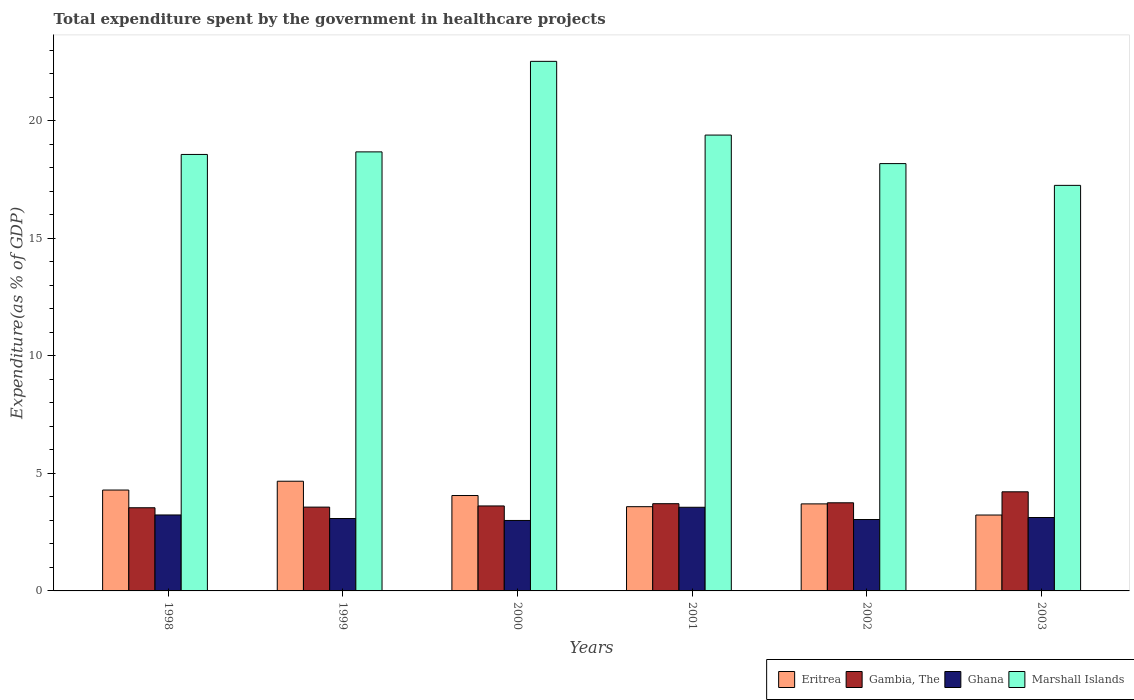Are the number of bars on each tick of the X-axis equal?
Provide a succinct answer. Yes. How many bars are there on the 1st tick from the right?
Offer a terse response. 4. What is the label of the 3rd group of bars from the left?
Offer a very short reply. 2000. In how many cases, is the number of bars for a given year not equal to the number of legend labels?
Make the answer very short. 0. What is the total expenditure spent by the government in healthcare projects in Marshall Islands in 2002?
Your answer should be compact. 18.18. Across all years, what is the maximum total expenditure spent by the government in healthcare projects in Marshall Islands?
Offer a terse response. 22.53. Across all years, what is the minimum total expenditure spent by the government in healthcare projects in Marshall Islands?
Your answer should be compact. 17.26. What is the total total expenditure spent by the government in healthcare projects in Eritrea in the graph?
Your answer should be compact. 23.54. What is the difference between the total expenditure spent by the government in healthcare projects in Ghana in 1998 and that in 2000?
Keep it short and to the point. 0.23. What is the difference between the total expenditure spent by the government in healthcare projects in Gambia, The in 2000 and the total expenditure spent by the government in healthcare projects in Eritrea in 2001?
Offer a terse response. 0.03. What is the average total expenditure spent by the government in healthcare projects in Ghana per year?
Offer a very short reply. 3.17. In the year 2001, what is the difference between the total expenditure spent by the government in healthcare projects in Eritrea and total expenditure spent by the government in healthcare projects in Marshall Islands?
Ensure brevity in your answer.  -15.81. What is the ratio of the total expenditure spent by the government in healthcare projects in Marshall Islands in 2001 to that in 2003?
Provide a short and direct response. 1.12. Is the total expenditure spent by the government in healthcare projects in Gambia, The in 2000 less than that in 2001?
Your answer should be compact. Yes. What is the difference between the highest and the second highest total expenditure spent by the government in healthcare projects in Gambia, The?
Ensure brevity in your answer.  0.47. What is the difference between the highest and the lowest total expenditure spent by the government in healthcare projects in Ghana?
Ensure brevity in your answer.  0.56. In how many years, is the total expenditure spent by the government in healthcare projects in Gambia, The greater than the average total expenditure spent by the government in healthcare projects in Gambia, The taken over all years?
Keep it short and to the point. 2. What does the 4th bar from the left in 2002 represents?
Your answer should be compact. Marshall Islands. What does the 3rd bar from the right in 2000 represents?
Make the answer very short. Gambia, The. Are all the bars in the graph horizontal?
Your response must be concise. No. How many years are there in the graph?
Provide a succinct answer. 6. Are the values on the major ticks of Y-axis written in scientific E-notation?
Keep it short and to the point. No. Does the graph contain grids?
Your answer should be very brief. No. Where does the legend appear in the graph?
Your response must be concise. Bottom right. How are the legend labels stacked?
Your answer should be very brief. Horizontal. What is the title of the graph?
Your response must be concise. Total expenditure spent by the government in healthcare projects. Does "Latin America(all income levels)" appear as one of the legend labels in the graph?
Your response must be concise. No. What is the label or title of the Y-axis?
Your answer should be very brief. Expenditure(as % of GDP). What is the Expenditure(as % of GDP) of Eritrea in 1998?
Your answer should be very brief. 4.29. What is the Expenditure(as % of GDP) of Gambia, The in 1998?
Your answer should be compact. 3.54. What is the Expenditure(as % of GDP) in Ghana in 1998?
Your response must be concise. 3.23. What is the Expenditure(as % of GDP) in Marshall Islands in 1998?
Offer a terse response. 18.57. What is the Expenditure(as % of GDP) in Eritrea in 1999?
Keep it short and to the point. 4.67. What is the Expenditure(as % of GDP) in Gambia, The in 1999?
Keep it short and to the point. 3.57. What is the Expenditure(as % of GDP) of Ghana in 1999?
Keep it short and to the point. 3.08. What is the Expenditure(as % of GDP) in Marshall Islands in 1999?
Offer a very short reply. 18.68. What is the Expenditure(as % of GDP) in Eritrea in 2000?
Keep it short and to the point. 4.06. What is the Expenditure(as % of GDP) in Gambia, The in 2000?
Ensure brevity in your answer.  3.62. What is the Expenditure(as % of GDP) of Ghana in 2000?
Ensure brevity in your answer.  3. What is the Expenditure(as % of GDP) in Marshall Islands in 2000?
Offer a terse response. 22.53. What is the Expenditure(as % of GDP) in Eritrea in 2001?
Provide a short and direct response. 3.58. What is the Expenditure(as % of GDP) in Gambia, The in 2001?
Give a very brief answer. 3.71. What is the Expenditure(as % of GDP) in Ghana in 2001?
Provide a succinct answer. 3.56. What is the Expenditure(as % of GDP) in Marshall Islands in 2001?
Your answer should be compact. 19.4. What is the Expenditure(as % of GDP) in Eritrea in 2002?
Give a very brief answer. 3.7. What is the Expenditure(as % of GDP) in Gambia, The in 2002?
Offer a very short reply. 3.75. What is the Expenditure(as % of GDP) of Ghana in 2002?
Offer a very short reply. 3.04. What is the Expenditure(as % of GDP) of Marshall Islands in 2002?
Keep it short and to the point. 18.18. What is the Expenditure(as % of GDP) of Eritrea in 2003?
Make the answer very short. 3.23. What is the Expenditure(as % of GDP) in Gambia, The in 2003?
Give a very brief answer. 4.22. What is the Expenditure(as % of GDP) of Ghana in 2003?
Give a very brief answer. 3.12. What is the Expenditure(as % of GDP) of Marshall Islands in 2003?
Make the answer very short. 17.26. Across all years, what is the maximum Expenditure(as % of GDP) of Eritrea?
Give a very brief answer. 4.67. Across all years, what is the maximum Expenditure(as % of GDP) in Gambia, The?
Provide a short and direct response. 4.22. Across all years, what is the maximum Expenditure(as % of GDP) of Ghana?
Make the answer very short. 3.56. Across all years, what is the maximum Expenditure(as % of GDP) of Marshall Islands?
Your response must be concise. 22.53. Across all years, what is the minimum Expenditure(as % of GDP) in Eritrea?
Offer a very short reply. 3.23. Across all years, what is the minimum Expenditure(as % of GDP) in Gambia, The?
Provide a succinct answer. 3.54. Across all years, what is the minimum Expenditure(as % of GDP) of Ghana?
Ensure brevity in your answer.  3. Across all years, what is the minimum Expenditure(as % of GDP) in Marshall Islands?
Offer a terse response. 17.26. What is the total Expenditure(as % of GDP) in Eritrea in the graph?
Your answer should be very brief. 23.54. What is the total Expenditure(as % of GDP) in Gambia, The in the graph?
Offer a very short reply. 22.4. What is the total Expenditure(as % of GDP) in Ghana in the graph?
Your response must be concise. 19.03. What is the total Expenditure(as % of GDP) in Marshall Islands in the graph?
Your response must be concise. 114.62. What is the difference between the Expenditure(as % of GDP) in Eritrea in 1998 and that in 1999?
Ensure brevity in your answer.  -0.37. What is the difference between the Expenditure(as % of GDP) in Gambia, The in 1998 and that in 1999?
Offer a very short reply. -0.03. What is the difference between the Expenditure(as % of GDP) of Ghana in 1998 and that in 1999?
Ensure brevity in your answer.  0.15. What is the difference between the Expenditure(as % of GDP) of Marshall Islands in 1998 and that in 1999?
Ensure brevity in your answer.  -0.11. What is the difference between the Expenditure(as % of GDP) in Eritrea in 1998 and that in 2000?
Offer a very short reply. 0.23. What is the difference between the Expenditure(as % of GDP) of Gambia, The in 1998 and that in 2000?
Provide a short and direct response. -0.08. What is the difference between the Expenditure(as % of GDP) in Ghana in 1998 and that in 2000?
Provide a short and direct response. 0.23. What is the difference between the Expenditure(as % of GDP) of Marshall Islands in 1998 and that in 2000?
Your response must be concise. -3.96. What is the difference between the Expenditure(as % of GDP) in Eritrea in 1998 and that in 2001?
Provide a succinct answer. 0.71. What is the difference between the Expenditure(as % of GDP) in Gambia, The in 1998 and that in 2001?
Provide a short and direct response. -0.17. What is the difference between the Expenditure(as % of GDP) of Ghana in 1998 and that in 2001?
Your answer should be very brief. -0.33. What is the difference between the Expenditure(as % of GDP) in Marshall Islands in 1998 and that in 2001?
Offer a terse response. -0.82. What is the difference between the Expenditure(as % of GDP) in Eritrea in 1998 and that in 2002?
Provide a short and direct response. 0.59. What is the difference between the Expenditure(as % of GDP) of Gambia, The in 1998 and that in 2002?
Your answer should be very brief. -0.21. What is the difference between the Expenditure(as % of GDP) of Ghana in 1998 and that in 2002?
Your answer should be compact. 0.19. What is the difference between the Expenditure(as % of GDP) of Marshall Islands in 1998 and that in 2002?
Offer a terse response. 0.39. What is the difference between the Expenditure(as % of GDP) of Eritrea in 1998 and that in 2003?
Your answer should be very brief. 1.06. What is the difference between the Expenditure(as % of GDP) in Gambia, The in 1998 and that in 2003?
Make the answer very short. -0.68. What is the difference between the Expenditure(as % of GDP) of Ghana in 1998 and that in 2003?
Your response must be concise. 0.11. What is the difference between the Expenditure(as % of GDP) in Marshall Islands in 1998 and that in 2003?
Provide a short and direct response. 1.32. What is the difference between the Expenditure(as % of GDP) in Eritrea in 1999 and that in 2000?
Your answer should be compact. 0.61. What is the difference between the Expenditure(as % of GDP) in Gambia, The in 1999 and that in 2000?
Keep it short and to the point. -0.05. What is the difference between the Expenditure(as % of GDP) of Ghana in 1999 and that in 2000?
Provide a short and direct response. 0.08. What is the difference between the Expenditure(as % of GDP) in Marshall Islands in 1999 and that in 2000?
Offer a very short reply. -3.85. What is the difference between the Expenditure(as % of GDP) in Eritrea in 1999 and that in 2001?
Provide a short and direct response. 1.08. What is the difference between the Expenditure(as % of GDP) in Gambia, The in 1999 and that in 2001?
Your response must be concise. -0.15. What is the difference between the Expenditure(as % of GDP) of Ghana in 1999 and that in 2001?
Provide a succinct answer. -0.48. What is the difference between the Expenditure(as % of GDP) in Marshall Islands in 1999 and that in 2001?
Keep it short and to the point. -0.72. What is the difference between the Expenditure(as % of GDP) in Eritrea in 1999 and that in 2002?
Your answer should be very brief. 0.96. What is the difference between the Expenditure(as % of GDP) in Gambia, The in 1999 and that in 2002?
Give a very brief answer. -0.18. What is the difference between the Expenditure(as % of GDP) of Ghana in 1999 and that in 2002?
Make the answer very short. 0.04. What is the difference between the Expenditure(as % of GDP) of Marshall Islands in 1999 and that in 2002?
Provide a short and direct response. 0.5. What is the difference between the Expenditure(as % of GDP) in Eritrea in 1999 and that in 2003?
Your answer should be compact. 1.44. What is the difference between the Expenditure(as % of GDP) of Gambia, The in 1999 and that in 2003?
Offer a terse response. -0.65. What is the difference between the Expenditure(as % of GDP) of Ghana in 1999 and that in 2003?
Offer a terse response. -0.04. What is the difference between the Expenditure(as % of GDP) in Marshall Islands in 1999 and that in 2003?
Provide a short and direct response. 1.42. What is the difference between the Expenditure(as % of GDP) in Eritrea in 2000 and that in 2001?
Keep it short and to the point. 0.48. What is the difference between the Expenditure(as % of GDP) in Gambia, The in 2000 and that in 2001?
Provide a short and direct response. -0.1. What is the difference between the Expenditure(as % of GDP) of Ghana in 2000 and that in 2001?
Offer a terse response. -0.56. What is the difference between the Expenditure(as % of GDP) in Marshall Islands in 2000 and that in 2001?
Offer a terse response. 3.14. What is the difference between the Expenditure(as % of GDP) in Eritrea in 2000 and that in 2002?
Offer a very short reply. 0.36. What is the difference between the Expenditure(as % of GDP) of Gambia, The in 2000 and that in 2002?
Offer a very short reply. -0.13. What is the difference between the Expenditure(as % of GDP) of Ghana in 2000 and that in 2002?
Offer a very short reply. -0.04. What is the difference between the Expenditure(as % of GDP) of Marshall Islands in 2000 and that in 2002?
Your response must be concise. 4.35. What is the difference between the Expenditure(as % of GDP) of Eritrea in 2000 and that in 2003?
Provide a short and direct response. 0.83. What is the difference between the Expenditure(as % of GDP) in Gambia, The in 2000 and that in 2003?
Your answer should be very brief. -0.6. What is the difference between the Expenditure(as % of GDP) of Ghana in 2000 and that in 2003?
Your answer should be compact. -0.13. What is the difference between the Expenditure(as % of GDP) in Marshall Islands in 2000 and that in 2003?
Make the answer very short. 5.28. What is the difference between the Expenditure(as % of GDP) in Eritrea in 2001 and that in 2002?
Ensure brevity in your answer.  -0.12. What is the difference between the Expenditure(as % of GDP) in Gambia, The in 2001 and that in 2002?
Make the answer very short. -0.04. What is the difference between the Expenditure(as % of GDP) in Ghana in 2001 and that in 2002?
Offer a terse response. 0.52. What is the difference between the Expenditure(as % of GDP) of Marshall Islands in 2001 and that in 2002?
Provide a short and direct response. 1.21. What is the difference between the Expenditure(as % of GDP) of Eritrea in 2001 and that in 2003?
Ensure brevity in your answer.  0.36. What is the difference between the Expenditure(as % of GDP) of Gambia, The in 2001 and that in 2003?
Your response must be concise. -0.51. What is the difference between the Expenditure(as % of GDP) of Ghana in 2001 and that in 2003?
Your answer should be compact. 0.44. What is the difference between the Expenditure(as % of GDP) in Marshall Islands in 2001 and that in 2003?
Give a very brief answer. 2.14. What is the difference between the Expenditure(as % of GDP) of Eritrea in 2002 and that in 2003?
Offer a very short reply. 0.47. What is the difference between the Expenditure(as % of GDP) of Gambia, The in 2002 and that in 2003?
Give a very brief answer. -0.47. What is the difference between the Expenditure(as % of GDP) in Ghana in 2002 and that in 2003?
Provide a short and direct response. -0.09. What is the difference between the Expenditure(as % of GDP) of Marshall Islands in 2002 and that in 2003?
Your answer should be compact. 0.93. What is the difference between the Expenditure(as % of GDP) in Eritrea in 1998 and the Expenditure(as % of GDP) in Gambia, The in 1999?
Provide a succinct answer. 0.73. What is the difference between the Expenditure(as % of GDP) in Eritrea in 1998 and the Expenditure(as % of GDP) in Ghana in 1999?
Ensure brevity in your answer.  1.21. What is the difference between the Expenditure(as % of GDP) in Eritrea in 1998 and the Expenditure(as % of GDP) in Marshall Islands in 1999?
Your answer should be compact. -14.39. What is the difference between the Expenditure(as % of GDP) in Gambia, The in 1998 and the Expenditure(as % of GDP) in Ghana in 1999?
Offer a very short reply. 0.46. What is the difference between the Expenditure(as % of GDP) of Gambia, The in 1998 and the Expenditure(as % of GDP) of Marshall Islands in 1999?
Keep it short and to the point. -15.14. What is the difference between the Expenditure(as % of GDP) in Ghana in 1998 and the Expenditure(as % of GDP) in Marshall Islands in 1999?
Your answer should be compact. -15.45. What is the difference between the Expenditure(as % of GDP) in Eritrea in 1998 and the Expenditure(as % of GDP) in Gambia, The in 2000?
Ensure brevity in your answer.  0.68. What is the difference between the Expenditure(as % of GDP) in Eritrea in 1998 and the Expenditure(as % of GDP) in Ghana in 2000?
Offer a very short reply. 1.29. What is the difference between the Expenditure(as % of GDP) of Eritrea in 1998 and the Expenditure(as % of GDP) of Marshall Islands in 2000?
Provide a succinct answer. -18.24. What is the difference between the Expenditure(as % of GDP) of Gambia, The in 1998 and the Expenditure(as % of GDP) of Ghana in 2000?
Provide a short and direct response. 0.54. What is the difference between the Expenditure(as % of GDP) in Gambia, The in 1998 and the Expenditure(as % of GDP) in Marshall Islands in 2000?
Offer a terse response. -18.99. What is the difference between the Expenditure(as % of GDP) in Ghana in 1998 and the Expenditure(as % of GDP) in Marshall Islands in 2000?
Make the answer very short. -19.3. What is the difference between the Expenditure(as % of GDP) of Eritrea in 1998 and the Expenditure(as % of GDP) of Gambia, The in 2001?
Your answer should be compact. 0.58. What is the difference between the Expenditure(as % of GDP) of Eritrea in 1998 and the Expenditure(as % of GDP) of Ghana in 2001?
Make the answer very short. 0.73. What is the difference between the Expenditure(as % of GDP) of Eritrea in 1998 and the Expenditure(as % of GDP) of Marshall Islands in 2001?
Your answer should be compact. -15.1. What is the difference between the Expenditure(as % of GDP) of Gambia, The in 1998 and the Expenditure(as % of GDP) of Ghana in 2001?
Give a very brief answer. -0.02. What is the difference between the Expenditure(as % of GDP) of Gambia, The in 1998 and the Expenditure(as % of GDP) of Marshall Islands in 2001?
Make the answer very short. -15.86. What is the difference between the Expenditure(as % of GDP) in Ghana in 1998 and the Expenditure(as % of GDP) in Marshall Islands in 2001?
Keep it short and to the point. -16.16. What is the difference between the Expenditure(as % of GDP) in Eritrea in 1998 and the Expenditure(as % of GDP) in Gambia, The in 2002?
Offer a very short reply. 0.54. What is the difference between the Expenditure(as % of GDP) in Eritrea in 1998 and the Expenditure(as % of GDP) in Ghana in 2002?
Your answer should be compact. 1.25. What is the difference between the Expenditure(as % of GDP) of Eritrea in 1998 and the Expenditure(as % of GDP) of Marshall Islands in 2002?
Offer a terse response. -13.89. What is the difference between the Expenditure(as % of GDP) in Gambia, The in 1998 and the Expenditure(as % of GDP) in Ghana in 2002?
Provide a short and direct response. 0.5. What is the difference between the Expenditure(as % of GDP) in Gambia, The in 1998 and the Expenditure(as % of GDP) in Marshall Islands in 2002?
Provide a succinct answer. -14.64. What is the difference between the Expenditure(as % of GDP) in Ghana in 1998 and the Expenditure(as % of GDP) in Marshall Islands in 2002?
Your answer should be compact. -14.95. What is the difference between the Expenditure(as % of GDP) of Eritrea in 1998 and the Expenditure(as % of GDP) of Gambia, The in 2003?
Offer a terse response. 0.08. What is the difference between the Expenditure(as % of GDP) in Eritrea in 1998 and the Expenditure(as % of GDP) in Ghana in 2003?
Your answer should be very brief. 1.17. What is the difference between the Expenditure(as % of GDP) of Eritrea in 1998 and the Expenditure(as % of GDP) of Marshall Islands in 2003?
Give a very brief answer. -12.96. What is the difference between the Expenditure(as % of GDP) of Gambia, The in 1998 and the Expenditure(as % of GDP) of Ghana in 2003?
Offer a terse response. 0.41. What is the difference between the Expenditure(as % of GDP) in Gambia, The in 1998 and the Expenditure(as % of GDP) in Marshall Islands in 2003?
Your answer should be compact. -13.72. What is the difference between the Expenditure(as % of GDP) of Ghana in 1998 and the Expenditure(as % of GDP) of Marshall Islands in 2003?
Offer a very short reply. -14.02. What is the difference between the Expenditure(as % of GDP) in Eritrea in 1999 and the Expenditure(as % of GDP) in Gambia, The in 2000?
Offer a terse response. 1.05. What is the difference between the Expenditure(as % of GDP) in Eritrea in 1999 and the Expenditure(as % of GDP) in Ghana in 2000?
Your response must be concise. 1.67. What is the difference between the Expenditure(as % of GDP) in Eritrea in 1999 and the Expenditure(as % of GDP) in Marshall Islands in 2000?
Provide a succinct answer. -17.87. What is the difference between the Expenditure(as % of GDP) in Gambia, The in 1999 and the Expenditure(as % of GDP) in Ghana in 2000?
Offer a very short reply. 0.57. What is the difference between the Expenditure(as % of GDP) of Gambia, The in 1999 and the Expenditure(as % of GDP) of Marshall Islands in 2000?
Your answer should be very brief. -18.97. What is the difference between the Expenditure(as % of GDP) of Ghana in 1999 and the Expenditure(as % of GDP) of Marshall Islands in 2000?
Your response must be concise. -19.45. What is the difference between the Expenditure(as % of GDP) of Eritrea in 1999 and the Expenditure(as % of GDP) of Gambia, The in 2001?
Your answer should be compact. 0.96. What is the difference between the Expenditure(as % of GDP) in Eritrea in 1999 and the Expenditure(as % of GDP) in Ghana in 2001?
Your answer should be compact. 1.11. What is the difference between the Expenditure(as % of GDP) of Eritrea in 1999 and the Expenditure(as % of GDP) of Marshall Islands in 2001?
Give a very brief answer. -14.73. What is the difference between the Expenditure(as % of GDP) in Gambia, The in 1999 and the Expenditure(as % of GDP) in Ghana in 2001?
Your response must be concise. 0.01. What is the difference between the Expenditure(as % of GDP) in Gambia, The in 1999 and the Expenditure(as % of GDP) in Marshall Islands in 2001?
Give a very brief answer. -15.83. What is the difference between the Expenditure(as % of GDP) in Ghana in 1999 and the Expenditure(as % of GDP) in Marshall Islands in 2001?
Ensure brevity in your answer.  -16.32. What is the difference between the Expenditure(as % of GDP) of Eritrea in 1999 and the Expenditure(as % of GDP) of Gambia, The in 2002?
Your answer should be compact. 0.92. What is the difference between the Expenditure(as % of GDP) of Eritrea in 1999 and the Expenditure(as % of GDP) of Ghana in 2002?
Offer a terse response. 1.63. What is the difference between the Expenditure(as % of GDP) in Eritrea in 1999 and the Expenditure(as % of GDP) in Marshall Islands in 2002?
Offer a terse response. -13.52. What is the difference between the Expenditure(as % of GDP) in Gambia, The in 1999 and the Expenditure(as % of GDP) in Ghana in 2002?
Ensure brevity in your answer.  0.53. What is the difference between the Expenditure(as % of GDP) of Gambia, The in 1999 and the Expenditure(as % of GDP) of Marshall Islands in 2002?
Your answer should be compact. -14.62. What is the difference between the Expenditure(as % of GDP) in Ghana in 1999 and the Expenditure(as % of GDP) in Marshall Islands in 2002?
Your answer should be compact. -15.1. What is the difference between the Expenditure(as % of GDP) in Eritrea in 1999 and the Expenditure(as % of GDP) in Gambia, The in 2003?
Make the answer very short. 0.45. What is the difference between the Expenditure(as % of GDP) in Eritrea in 1999 and the Expenditure(as % of GDP) in Ghana in 2003?
Keep it short and to the point. 1.54. What is the difference between the Expenditure(as % of GDP) of Eritrea in 1999 and the Expenditure(as % of GDP) of Marshall Islands in 2003?
Your answer should be compact. -12.59. What is the difference between the Expenditure(as % of GDP) in Gambia, The in 1999 and the Expenditure(as % of GDP) in Ghana in 2003?
Keep it short and to the point. 0.44. What is the difference between the Expenditure(as % of GDP) in Gambia, The in 1999 and the Expenditure(as % of GDP) in Marshall Islands in 2003?
Your response must be concise. -13.69. What is the difference between the Expenditure(as % of GDP) in Ghana in 1999 and the Expenditure(as % of GDP) in Marshall Islands in 2003?
Your response must be concise. -14.18. What is the difference between the Expenditure(as % of GDP) of Eritrea in 2000 and the Expenditure(as % of GDP) of Gambia, The in 2001?
Make the answer very short. 0.35. What is the difference between the Expenditure(as % of GDP) of Eritrea in 2000 and the Expenditure(as % of GDP) of Marshall Islands in 2001?
Your answer should be very brief. -15.34. What is the difference between the Expenditure(as % of GDP) of Gambia, The in 2000 and the Expenditure(as % of GDP) of Ghana in 2001?
Make the answer very short. 0.06. What is the difference between the Expenditure(as % of GDP) of Gambia, The in 2000 and the Expenditure(as % of GDP) of Marshall Islands in 2001?
Offer a very short reply. -15.78. What is the difference between the Expenditure(as % of GDP) of Ghana in 2000 and the Expenditure(as % of GDP) of Marshall Islands in 2001?
Offer a terse response. -16.4. What is the difference between the Expenditure(as % of GDP) of Eritrea in 2000 and the Expenditure(as % of GDP) of Gambia, The in 2002?
Offer a very short reply. 0.31. What is the difference between the Expenditure(as % of GDP) of Eritrea in 2000 and the Expenditure(as % of GDP) of Ghana in 2002?
Make the answer very short. 1.02. What is the difference between the Expenditure(as % of GDP) of Eritrea in 2000 and the Expenditure(as % of GDP) of Marshall Islands in 2002?
Give a very brief answer. -14.12. What is the difference between the Expenditure(as % of GDP) of Gambia, The in 2000 and the Expenditure(as % of GDP) of Ghana in 2002?
Provide a succinct answer. 0.58. What is the difference between the Expenditure(as % of GDP) of Gambia, The in 2000 and the Expenditure(as % of GDP) of Marshall Islands in 2002?
Your response must be concise. -14.57. What is the difference between the Expenditure(as % of GDP) in Ghana in 2000 and the Expenditure(as % of GDP) in Marshall Islands in 2002?
Offer a very short reply. -15.18. What is the difference between the Expenditure(as % of GDP) in Eritrea in 2000 and the Expenditure(as % of GDP) in Gambia, The in 2003?
Ensure brevity in your answer.  -0.16. What is the difference between the Expenditure(as % of GDP) of Eritrea in 2000 and the Expenditure(as % of GDP) of Ghana in 2003?
Your answer should be compact. 0.94. What is the difference between the Expenditure(as % of GDP) in Eritrea in 2000 and the Expenditure(as % of GDP) in Marshall Islands in 2003?
Your answer should be compact. -13.2. What is the difference between the Expenditure(as % of GDP) in Gambia, The in 2000 and the Expenditure(as % of GDP) in Ghana in 2003?
Offer a very short reply. 0.49. What is the difference between the Expenditure(as % of GDP) in Gambia, The in 2000 and the Expenditure(as % of GDP) in Marshall Islands in 2003?
Your answer should be compact. -13.64. What is the difference between the Expenditure(as % of GDP) of Ghana in 2000 and the Expenditure(as % of GDP) of Marshall Islands in 2003?
Your response must be concise. -14.26. What is the difference between the Expenditure(as % of GDP) of Eritrea in 2001 and the Expenditure(as % of GDP) of Gambia, The in 2002?
Your response must be concise. -0.17. What is the difference between the Expenditure(as % of GDP) in Eritrea in 2001 and the Expenditure(as % of GDP) in Ghana in 2002?
Provide a succinct answer. 0.55. What is the difference between the Expenditure(as % of GDP) of Eritrea in 2001 and the Expenditure(as % of GDP) of Marshall Islands in 2002?
Give a very brief answer. -14.6. What is the difference between the Expenditure(as % of GDP) in Gambia, The in 2001 and the Expenditure(as % of GDP) in Ghana in 2002?
Provide a succinct answer. 0.67. What is the difference between the Expenditure(as % of GDP) of Gambia, The in 2001 and the Expenditure(as % of GDP) of Marshall Islands in 2002?
Keep it short and to the point. -14.47. What is the difference between the Expenditure(as % of GDP) of Ghana in 2001 and the Expenditure(as % of GDP) of Marshall Islands in 2002?
Make the answer very short. -14.62. What is the difference between the Expenditure(as % of GDP) of Eritrea in 2001 and the Expenditure(as % of GDP) of Gambia, The in 2003?
Offer a very short reply. -0.63. What is the difference between the Expenditure(as % of GDP) in Eritrea in 2001 and the Expenditure(as % of GDP) in Ghana in 2003?
Ensure brevity in your answer.  0.46. What is the difference between the Expenditure(as % of GDP) in Eritrea in 2001 and the Expenditure(as % of GDP) in Marshall Islands in 2003?
Provide a short and direct response. -13.67. What is the difference between the Expenditure(as % of GDP) in Gambia, The in 2001 and the Expenditure(as % of GDP) in Ghana in 2003?
Give a very brief answer. 0.59. What is the difference between the Expenditure(as % of GDP) in Gambia, The in 2001 and the Expenditure(as % of GDP) in Marshall Islands in 2003?
Your response must be concise. -13.55. What is the difference between the Expenditure(as % of GDP) in Ghana in 2001 and the Expenditure(as % of GDP) in Marshall Islands in 2003?
Provide a succinct answer. -13.7. What is the difference between the Expenditure(as % of GDP) in Eritrea in 2002 and the Expenditure(as % of GDP) in Gambia, The in 2003?
Your answer should be very brief. -0.51. What is the difference between the Expenditure(as % of GDP) of Eritrea in 2002 and the Expenditure(as % of GDP) of Ghana in 2003?
Provide a succinct answer. 0.58. What is the difference between the Expenditure(as % of GDP) in Eritrea in 2002 and the Expenditure(as % of GDP) in Marshall Islands in 2003?
Give a very brief answer. -13.55. What is the difference between the Expenditure(as % of GDP) of Gambia, The in 2002 and the Expenditure(as % of GDP) of Ghana in 2003?
Your answer should be very brief. 0.63. What is the difference between the Expenditure(as % of GDP) in Gambia, The in 2002 and the Expenditure(as % of GDP) in Marshall Islands in 2003?
Offer a very short reply. -13.51. What is the difference between the Expenditure(as % of GDP) of Ghana in 2002 and the Expenditure(as % of GDP) of Marshall Islands in 2003?
Provide a short and direct response. -14.22. What is the average Expenditure(as % of GDP) in Eritrea per year?
Your response must be concise. 3.92. What is the average Expenditure(as % of GDP) in Gambia, The per year?
Provide a succinct answer. 3.73. What is the average Expenditure(as % of GDP) of Ghana per year?
Make the answer very short. 3.17. What is the average Expenditure(as % of GDP) in Marshall Islands per year?
Give a very brief answer. 19.1. In the year 1998, what is the difference between the Expenditure(as % of GDP) in Eritrea and Expenditure(as % of GDP) in Gambia, The?
Offer a very short reply. 0.75. In the year 1998, what is the difference between the Expenditure(as % of GDP) in Eritrea and Expenditure(as % of GDP) in Ghana?
Give a very brief answer. 1.06. In the year 1998, what is the difference between the Expenditure(as % of GDP) in Eritrea and Expenditure(as % of GDP) in Marshall Islands?
Your answer should be compact. -14.28. In the year 1998, what is the difference between the Expenditure(as % of GDP) in Gambia, The and Expenditure(as % of GDP) in Ghana?
Provide a short and direct response. 0.31. In the year 1998, what is the difference between the Expenditure(as % of GDP) in Gambia, The and Expenditure(as % of GDP) in Marshall Islands?
Offer a terse response. -15.03. In the year 1998, what is the difference between the Expenditure(as % of GDP) of Ghana and Expenditure(as % of GDP) of Marshall Islands?
Provide a short and direct response. -15.34. In the year 1999, what is the difference between the Expenditure(as % of GDP) in Eritrea and Expenditure(as % of GDP) in Gambia, The?
Your answer should be very brief. 1.1. In the year 1999, what is the difference between the Expenditure(as % of GDP) of Eritrea and Expenditure(as % of GDP) of Ghana?
Offer a terse response. 1.59. In the year 1999, what is the difference between the Expenditure(as % of GDP) in Eritrea and Expenditure(as % of GDP) in Marshall Islands?
Your answer should be very brief. -14.01. In the year 1999, what is the difference between the Expenditure(as % of GDP) of Gambia, The and Expenditure(as % of GDP) of Ghana?
Your answer should be compact. 0.49. In the year 1999, what is the difference between the Expenditure(as % of GDP) in Gambia, The and Expenditure(as % of GDP) in Marshall Islands?
Offer a terse response. -15.12. In the year 1999, what is the difference between the Expenditure(as % of GDP) of Ghana and Expenditure(as % of GDP) of Marshall Islands?
Give a very brief answer. -15.6. In the year 2000, what is the difference between the Expenditure(as % of GDP) of Eritrea and Expenditure(as % of GDP) of Gambia, The?
Your response must be concise. 0.44. In the year 2000, what is the difference between the Expenditure(as % of GDP) in Eritrea and Expenditure(as % of GDP) in Ghana?
Provide a succinct answer. 1.06. In the year 2000, what is the difference between the Expenditure(as % of GDP) of Eritrea and Expenditure(as % of GDP) of Marshall Islands?
Offer a very short reply. -18.47. In the year 2000, what is the difference between the Expenditure(as % of GDP) in Gambia, The and Expenditure(as % of GDP) in Ghana?
Provide a short and direct response. 0.62. In the year 2000, what is the difference between the Expenditure(as % of GDP) in Gambia, The and Expenditure(as % of GDP) in Marshall Islands?
Give a very brief answer. -18.92. In the year 2000, what is the difference between the Expenditure(as % of GDP) of Ghana and Expenditure(as % of GDP) of Marshall Islands?
Provide a succinct answer. -19.53. In the year 2001, what is the difference between the Expenditure(as % of GDP) in Eritrea and Expenditure(as % of GDP) in Gambia, The?
Offer a very short reply. -0.13. In the year 2001, what is the difference between the Expenditure(as % of GDP) of Eritrea and Expenditure(as % of GDP) of Ghana?
Provide a short and direct response. 0.02. In the year 2001, what is the difference between the Expenditure(as % of GDP) in Eritrea and Expenditure(as % of GDP) in Marshall Islands?
Ensure brevity in your answer.  -15.81. In the year 2001, what is the difference between the Expenditure(as % of GDP) of Gambia, The and Expenditure(as % of GDP) of Ghana?
Offer a terse response. 0.15. In the year 2001, what is the difference between the Expenditure(as % of GDP) of Gambia, The and Expenditure(as % of GDP) of Marshall Islands?
Make the answer very short. -15.69. In the year 2001, what is the difference between the Expenditure(as % of GDP) of Ghana and Expenditure(as % of GDP) of Marshall Islands?
Make the answer very short. -15.84. In the year 2002, what is the difference between the Expenditure(as % of GDP) of Eritrea and Expenditure(as % of GDP) of Gambia, The?
Your answer should be compact. -0.05. In the year 2002, what is the difference between the Expenditure(as % of GDP) of Eritrea and Expenditure(as % of GDP) of Ghana?
Your response must be concise. 0.67. In the year 2002, what is the difference between the Expenditure(as % of GDP) of Eritrea and Expenditure(as % of GDP) of Marshall Islands?
Your answer should be compact. -14.48. In the year 2002, what is the difference between the Expenditure(as % of GDP) of Gambia, The and Expenditure(as % of GDP) of Ghana?
Provide a short and direct response. 0.71. In the year 2002, what is the difference between the Expenditure(as % of GDP) in Gambia, The and Expenditure(as % of GDP) in Marshall Islands?
Keep it short and to the point. -14.43. In the year 2002, what is the difference between the Expenditure(as % of GDP) of Ghana and Expenditure(as % of GDP) of Marshall Islands?
Your answer should be compact. -15.14. In the year 2003, what is the difference between the Expenditure(as % of GDP) of Eritrea and Expenditure(as % of GDP) of Gambia, The?
Keep it short and to the point. -0.99. In the year 2003, what is the difference between the Expenditure(as % of GDP) in Eritrea and Expenditure(as % of GDP) in Ghana?
Provide a succinct answer. 0.11. In the year 2003, what is the difference between the Expenditure(as % of GDP) in Eritrea and Expenditure(as % of GDP) in Marshall Islands?
Make the answer very short. -14.03. In the year 2003, what is the difference between the Expenditure(as % of GDP) in Gambia, The and Expenditure(as % of GDP) in Ghana?
Make the answer very short. 1.09. In the year 2003, what is the difference between the Expenditure(as % of GDP) of Gambia, The and Expenditure(as % of GDP) of Marshall Islands?
Make the answer very short. -13.04. In the year 2003, what is the difference between the Expenditure(as % of GDP) of Ghana and Expenditure(as % of GDP) of Marshall Islands?
Provide a short and direct response. -14.13. What is the ratio of the Expenditure(as % of GDP) of Eritrea in 1998 to that in 1999?
Provide a short and direct response. 0.92. What is the ratio of the Expenditure(as % of GDP) of Ghana in 1998 to that in 1999?
Your answer should be compact. 1.05. What is the ratio of the Expenditure(as % of GDP) of Eritrea in 1998 to that in 2000?
Your response must be concise. 1.06. What is the ratio of the Expenditure(as % of GDP) in Gambia, The in 1998 to that in 2000?
Keep it short and to the point. 0.98. What is the ratio of the Expenditure(as % of GDP) in Ghana in 1998 to that in 2000?
Offer a very short reply. 1.08. What is the ratio of the Expenditure(as % of GDP) in Marshall Islands in 1998 to that in 2000?
Give a very brief answer. 0.82. What is the ratio of the Expenditure(as % of GDP) of Eritrea in 1998 to that in 2001?
Ensure brevity in your answer.  1.2. What is the ratio of the Expenditure(as % of GDP) of Gambia, The in 1998 to that in 2001?
Keep it short and to the point. 0.95. What is the ratio of the Expenditure(as % of GDP) of Ghana in 1998 to that in 2001?
Provide a succinct answer. 0.91. What is the ratio of the Expenditure(as % of GDP) in Marshall Islands in 1998 to that in 2001?
Provide a succinct answer. 0.96. What is the ratio of the Expenditure(as % of GDP) in Eritrea in 1998 to that in 2002?
Your answer should be compact. 1.16. What is the ratio of the Expenditure(as % of GDP) in Gambia, The in 1998 to that in 2002?
Keep it short and to the point. 0.94. What is the ratio of the Expenditure(as % of GDP) in Ghana in 1998 to that in 2002?
Offer a very short reply. 1.06. What is the ratio of the Expenditure(as % of GDP) of Marshall Islands in 1998 to that in 2002?
Keep it short and to the point. 1.02. What is the ratio of the Expenditure(as % of GDP) in Eritrea in 1998 to that in 2003?
Make the answer very short. 1.33. What is the ratio of the Expenditure(as % of GDP) of Gambia, The in 1998 to that in 2003?
Your answer should be compact. 0.84. What is the ratio of the Expenditure(as % of GDP) of Ghana in 1998 to that in 2003?
Keep it short and to the point. 1.03. What is the ratio of the Expenditure(as % of GDP) of Marshall Islands in 1998 to that in 2003?
Your answer should be compact. 1.08. What is the ratio of the Expenditure(as % of GDP) of Eritrea in 1999 to that in 2000?
Provide a succinct answer. 1.15. What is the ratio of the Expenditure(as % of GDP) of Gambia, The in 1999 to that in 2000?
Offer a terse response. 0.99. What is the ratio of the Expenditure(as % of GDP) of Ghana in 1999 to that in 2000?
Provide a succinct answer. 1.03. What is the ratio of the Expenditure(as % of GDP) of Marshall Islands in 1999 to that in 2000?
Provide a succinct answer. 0.83. What is the ratio of the Expenditure(as % of GDP) in Eritrea in 1999 to that in 2001?
Make the answer very short. 1.3. What is the ratio of the Expenditure(as % of GDP) of Gambia, The in 1999 to that in 2001?
Offer a terse response. 0.96. What is the ratio of the Expenditure(as % of GDP) of Ghana in 1999 to that in 2001?
Offer a terse response. 0.87. What is the ratio of the Expenditure(as % of GDP) of Marshall Islands in 1999 to that in 2001?
Give a very brief answer. 0.96. What is the ratio of the Expenditure(as % of GDP) in Eritrea in 1999 to that in 2002?
Provide a short and direct response. 1.26. What is the ratio of the Expenditure(as % of GDP) in Gambia, The in 1999 to that in 2002?
Keep it short and to the point. 0.95. What is the ratio of the Expenditure(as % of GDP) of Ghana in 1999 to that in 2002?
Your answer should be very brief. 1.01. What is the ratio of the Expenditure(as % of GDP) of Marshall Islands in 1999 to that in 2002?
Your answer should be compact. 1.03. What is the ratio of the Expenditure(as % of GDP) in Eritrea in 1999 to that in 2003?
Provide a short and direct response. 1.45. What is the ratio of the Expenditure(as % of GDP) in Gambia, The in 1999 to that in 2003?
Your answer should be very brief. 0.85. What is the ratio of the Expenditure(as % of GDP) of Ghana in 1999 to that in 2003?
Keep it short and to the point. 0.99. What is the ratio of the Expenditure(as % of GDP) of Marshall Islands in 1999 to that in 2003?
Offer a very short reply. 1.08. What is the ratio of the Expenditure(as % of GDP) of Eritrea in 2000 to that in 2001?
Keep it short and to the point. 1.13. What is the ratio of the Expenditure(as % of GDP) of Gambia, The in 2000 to that in 2001?
Ensure brevity in your answer.  0.97. What is the ratio of the Expenditure(as % of GDP) in Ghana in 2000 to that in 2001?
Offer a very short reply. 0.84. What is the ratio of the Expenditure(as % of GDP) in Marshall Islands in 2000 to that in 2001?
Provide a short and direct response. 1.16. What is the ratio of the Expenditure(as % of GDP) in Eritrea in 2000 to that in 2002?
Keep it short and to the point. 1.1. What is the ratio of the Expenditure(as % of GDP) in Gambia, The in 2000 to that in 2002?
Make the answer very short. 0.96. What is the ratio of the Expenditure(as % of GDP) of Ghana in 2000 to that in 2002?
Make the answer very short. 0.99. What is the ratio of the Expenditure(as % of GDP) of Marshall Islands in 2000 to that in 2002?
Make the answer very short. 1.24. What is the ratio of the Expenditure(as % of GDP) in Eritrea in 2000 to that in 2003?
Your answer should be very brief. 1.26. What is the ratio of the Expenditure(as % of GDP) in Gambia, The in 2000 to that in 2003?
Make the answer very short. 0.86. What is the ratio of the Expenditure(as % of GDP) of Ghana in 2000 to that in 2003?
Your answer should be compact. 0.96. What is the ratio of the Expenditure(as % of GDP) of Marshall Islands in 2000 to that in 2003?
Offer a very short reply. 1.31. What is the ratio of the Expenditure(as % of GDP) in Eritrea in 2001 to that in 2002?
Offer a very short reply. 0.97. What is the ratio of the Expenditure(as % of GDP) of Gambia, The in 2001 to that in 2002?
Give a very brief answer. 0.99. What is the ratio of the Expenditure(as % of GDP) in Ghana in 2001 to that in 2002?
Provide a short and direct response. 1.17. What is the ratio of the Expenditure(as % of GDP) of Marshall Islands in 2001 to that in 2002?
Provide a short and direct response. 1.07. What is the ratio of the Expenditure(as % of GDP) in Eritrea in 2001 to that in 2003?
Your answer should be very brief. 1.11. What is the ratio of the Expenditure(as % of GDP) in Gambia, The in 2001 to that in 2003?
Offer a very short reply. 0.88. What is the ratio of the Expenditure(as % of GDP) of Ghana in 2001 to that in 2003?
Keep it short and to the point. 1.14. What is the ratio of the Expenditure(as % of GDP) in Marshall Islands in 2001 to that in 2003?
Keep it short and to the point. 1.12. What is the ratio of the Expenditure(as % of GDP) of Eritrea in 2002 to that in 2003?
Provide a short and direct response. 1.15. What is the ratio of the Expenditure(as % of GDP) in Gambia, The in 2002 to that in 2003?
Keep it short and to the point. 0.89. What is the ratio of the Expenditure(as % of GDP) of Ghana in 2002 to that in 2003?
Ensure brevity in your answer.  0.97. What is the ratio of the Expenditure(as % of GDP) in Marshall Islands in 2002 to that in 2003?
Make the answer very short. 1.05. What is the difference between the highest and the second highest Expenditure(as % of GDP) of Eritrea?
Keep it short and to the point. 0.37. What is the difference between the highest and the second highest Expenditure(as % of GDP) of Gambia, The?
Provide a short and direct response. 0.47. What is the difference between the highest and the second highest Expenditure(as % of GDP) of Ghana?
Ensure brevity in your answer.  0.33. What is the difference between the highest and the second highest Expenditure(as % of GDP) in Marshall Islands?
Offer a very short reply. 3.14. What is the difference between the highest and the lowest Expenditure(as % of GDP) in Eritrea?
Your answer should be compact. 1.44. What is the difference between the highest and the lowest Expenditure(as % of GDP) in Gambia, The?
Give a very brief answer. 0.68. What is the difference between the highest and the lowest Expenditure(as % of GDP) in Ghana?
Provide a succinct answer. 0.56. What is the difference between the highest and the lowest Expenditure(as % of GDP) in Marshall Islands?
Your response must be concise. 5.28. 